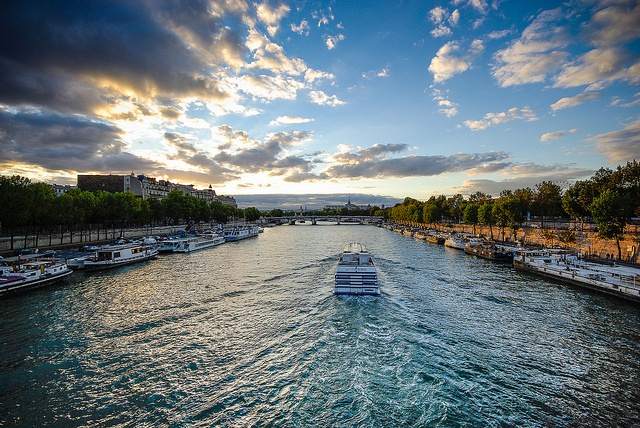Describe the objects in this image and their specific colors. I can see boat in black, darkgray, and gray tones, boat in black and gray tones, boat in black and gray tones, boat in black, gray, and darkgray tones, and boat in black, gray, blue, and darkgray tones in this image. 